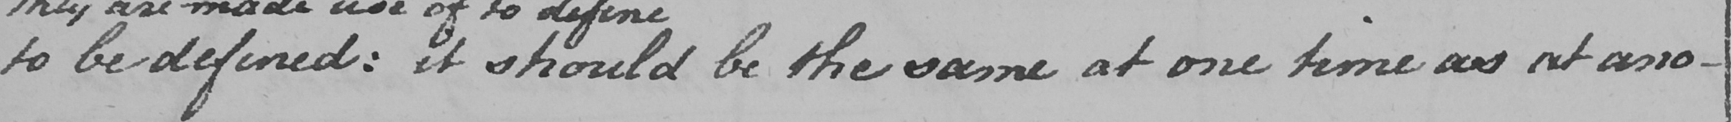Please provide the text content of this handwritten line. to be defined :  it should be the same at one time as at ano- 